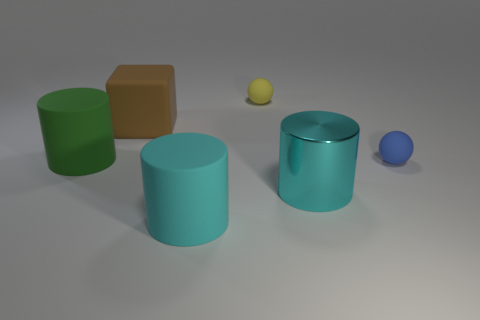Subtract all rubber cylinders. How many cylinders are left? 1 Subtract all brown balls. How many cyan cylinders are left? 2 Subtract all green cylinders. How many cylinders are left? 2 Subtract all balls. How many objects are left? 4 Add 3 small green shiny blocks. How many objects exist? 9 Subtract all purple spheres. Subtract all brown cylinders. How many spheres are left? 2 Subtract all things. Subtract all yellow shiny blocks. How many objects are left? 0 Add 6 big green cylinders. How many big green cylinders are left? 7 Add 3 small yellow metal cylinders. How many small yellow metal cylinders exist? 3 Subtract 0 brown spheres. How many objects are left? 6 